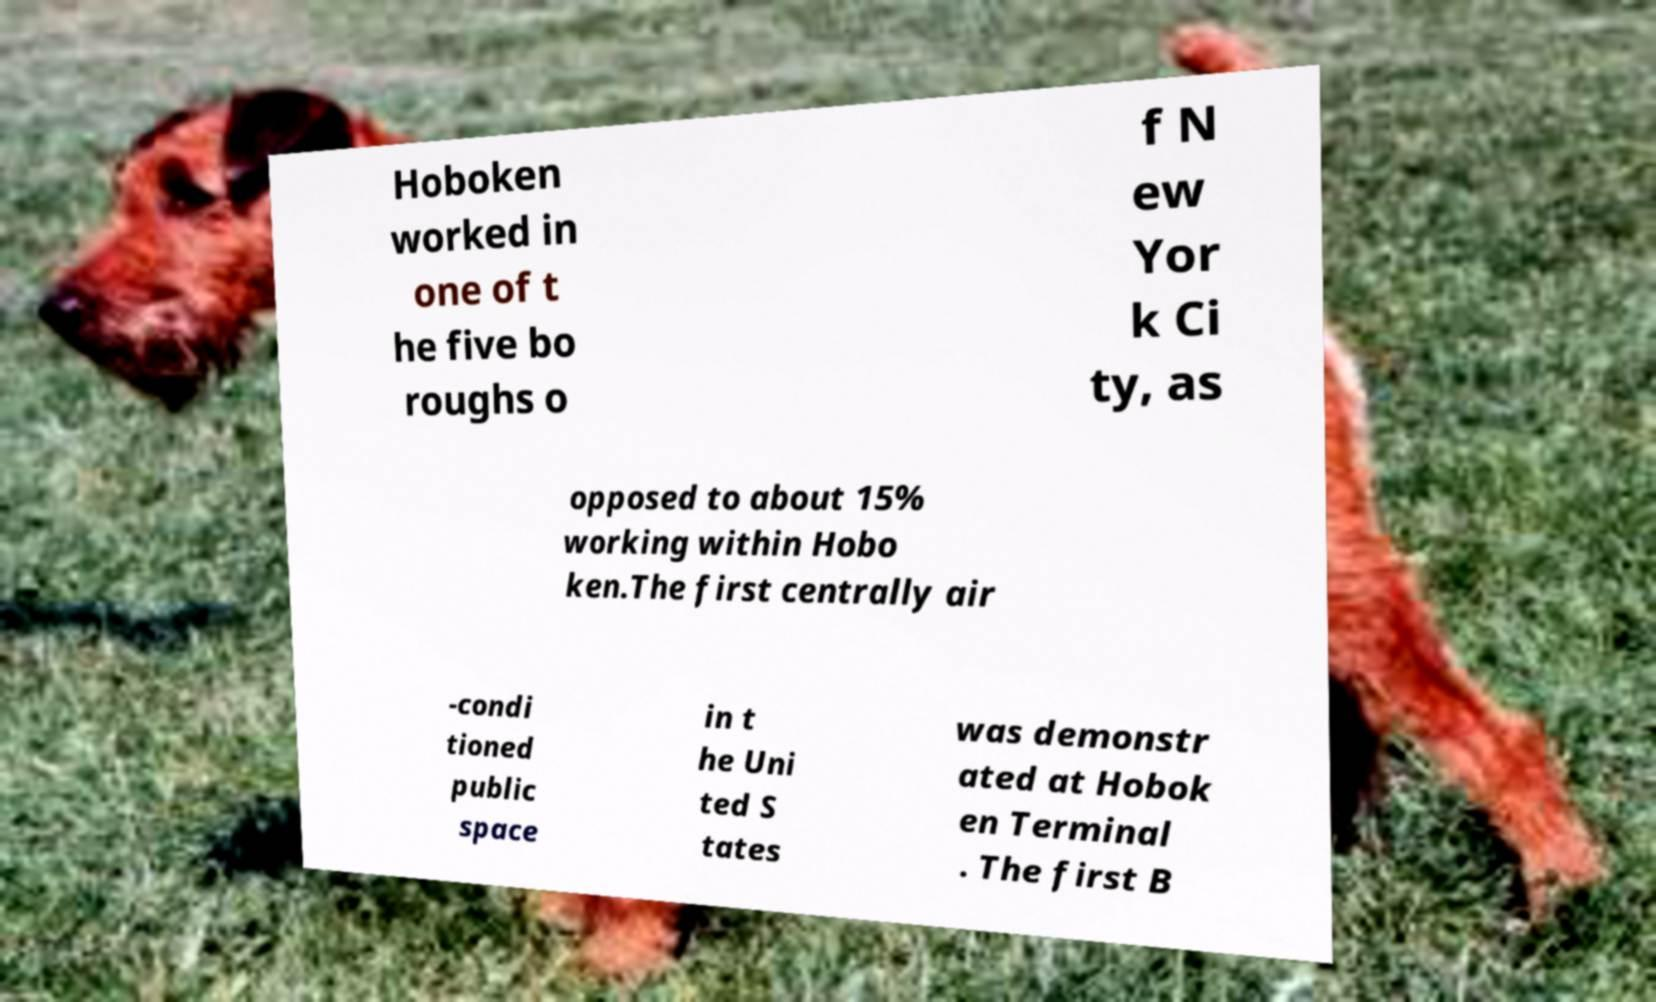Can you accurately transcribe the text from the provided image for me? Hoboken worked in one of t he five bo roughs o f N ew Yor k Ci ty, as opposed to about 15% working within Hobo ken.The first centrally air -condi tioned public space in t he Uni ted S tates was demonstr ated at Hobok en Terminal . The first B 